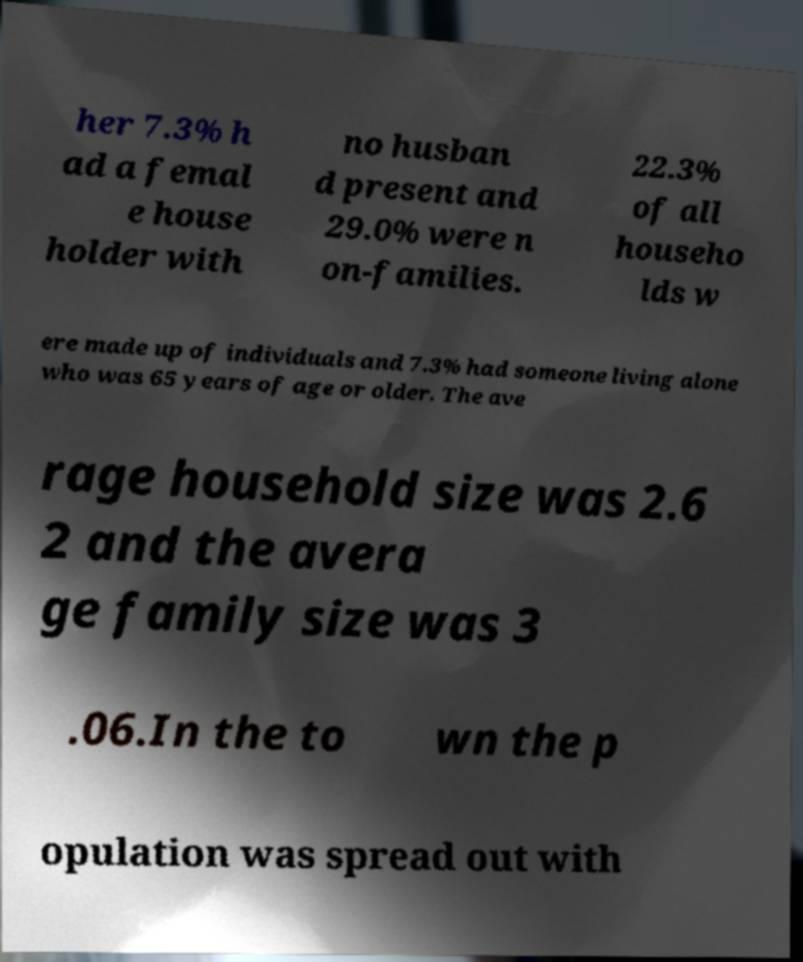Please identify and transcribe the text found in this image. her 7.3% h ad a femal e house holder with no husban d present and 29.0% were n on-families. 22.3% of all househo lds w ere made up of individuals and 7.3% had someone living alone who was 65 years of age or older. The ave rage household size was 2.6 2 and the avera ge family size was 3 .06.In the to wn the p opulation was spread out with 